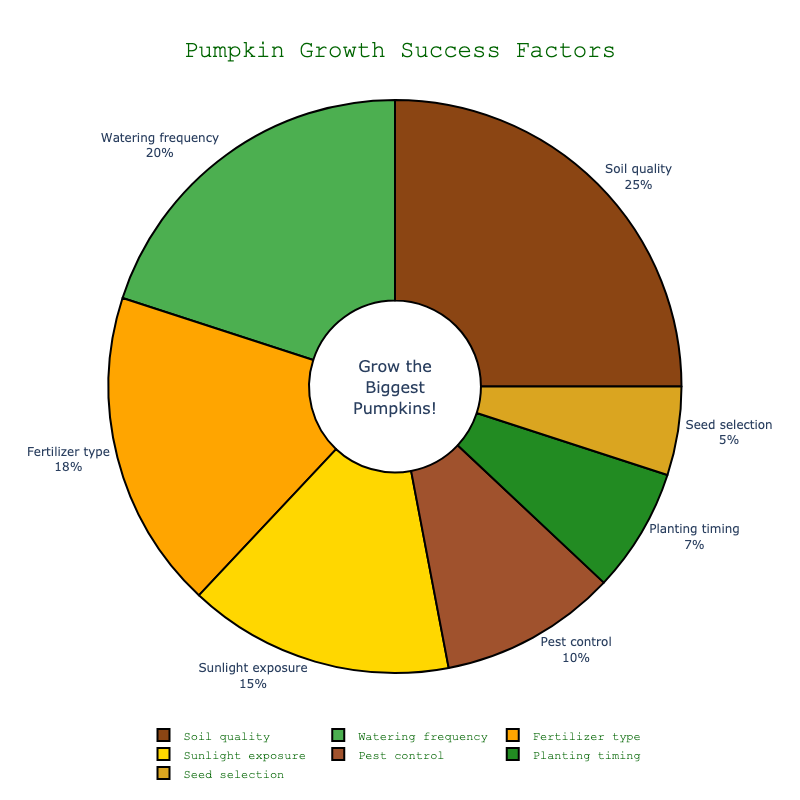what factor contributes the most to pumpkin growth success? By looking at the pie chart, the factor with the largest section represents the highest contribution. Soil quality comprises 25% of the total, which is the largest.
Answer: Soil quality what are the combined contributions of watering frequency and fertilizer type? To find the combined contributions, add the percentages for watering frequency and fertilizer type. Watering frequency is 20% and fertilizer type is 18%. Adding them gives 20% + 18% = 38%.
Answer: 38% which factor has a lower contribution: sunlight exposure or pest control? By comparing the sizes of the pie sections for sunlight exposure and pest control, sunlight exposure is 15% and pest control is 10%. Pest control has a lower contribution.
Answer: Pest control what percentage do the three smallest factors contribute together? Identify the three smallest factors: seed selection (5%), planting timing (7%), and pest control (10%). Their combined contribution is 5% + 7% + 10% = 22%.
Answer: 22% how much more important is soil quality compared to seed selection? By subtracting the percentage of seed selection from soil quality: 25% - 5% = 20%. Soil quality is 20 percentage points more important.
Answer: 20 percentage points which factors are colored green and yellow? Green is the second color used after brown and represents 'Watering frequency'. Yellow is used for 'Sunlight exposure' and 'Planting timing'.
Answer: Watering frequency, Sunlight exposure, Planting timing what is the difference between the contributions of fertilizer type and planting timing? Subtract the percentage of planting timing from fertilizer type: 18% - 7% = 11%. The difference in contribution is 11%.
Answer: 11% if pest control's contribution was increased by 5%, how would that impact its rank among other factors? Increasing pest control by 5% makes it 10% + 5% = 15%, equal to sunlight exposure. It would then rank equal to sunlight exposure and above planting timing and seed selection.
Answer: Equal to sunlight exposure which factor is shown in orange? Orange is the third color used in the pie chart after brown and green and represents 'Fertilizer type'.
Answer: Fertilizer type 